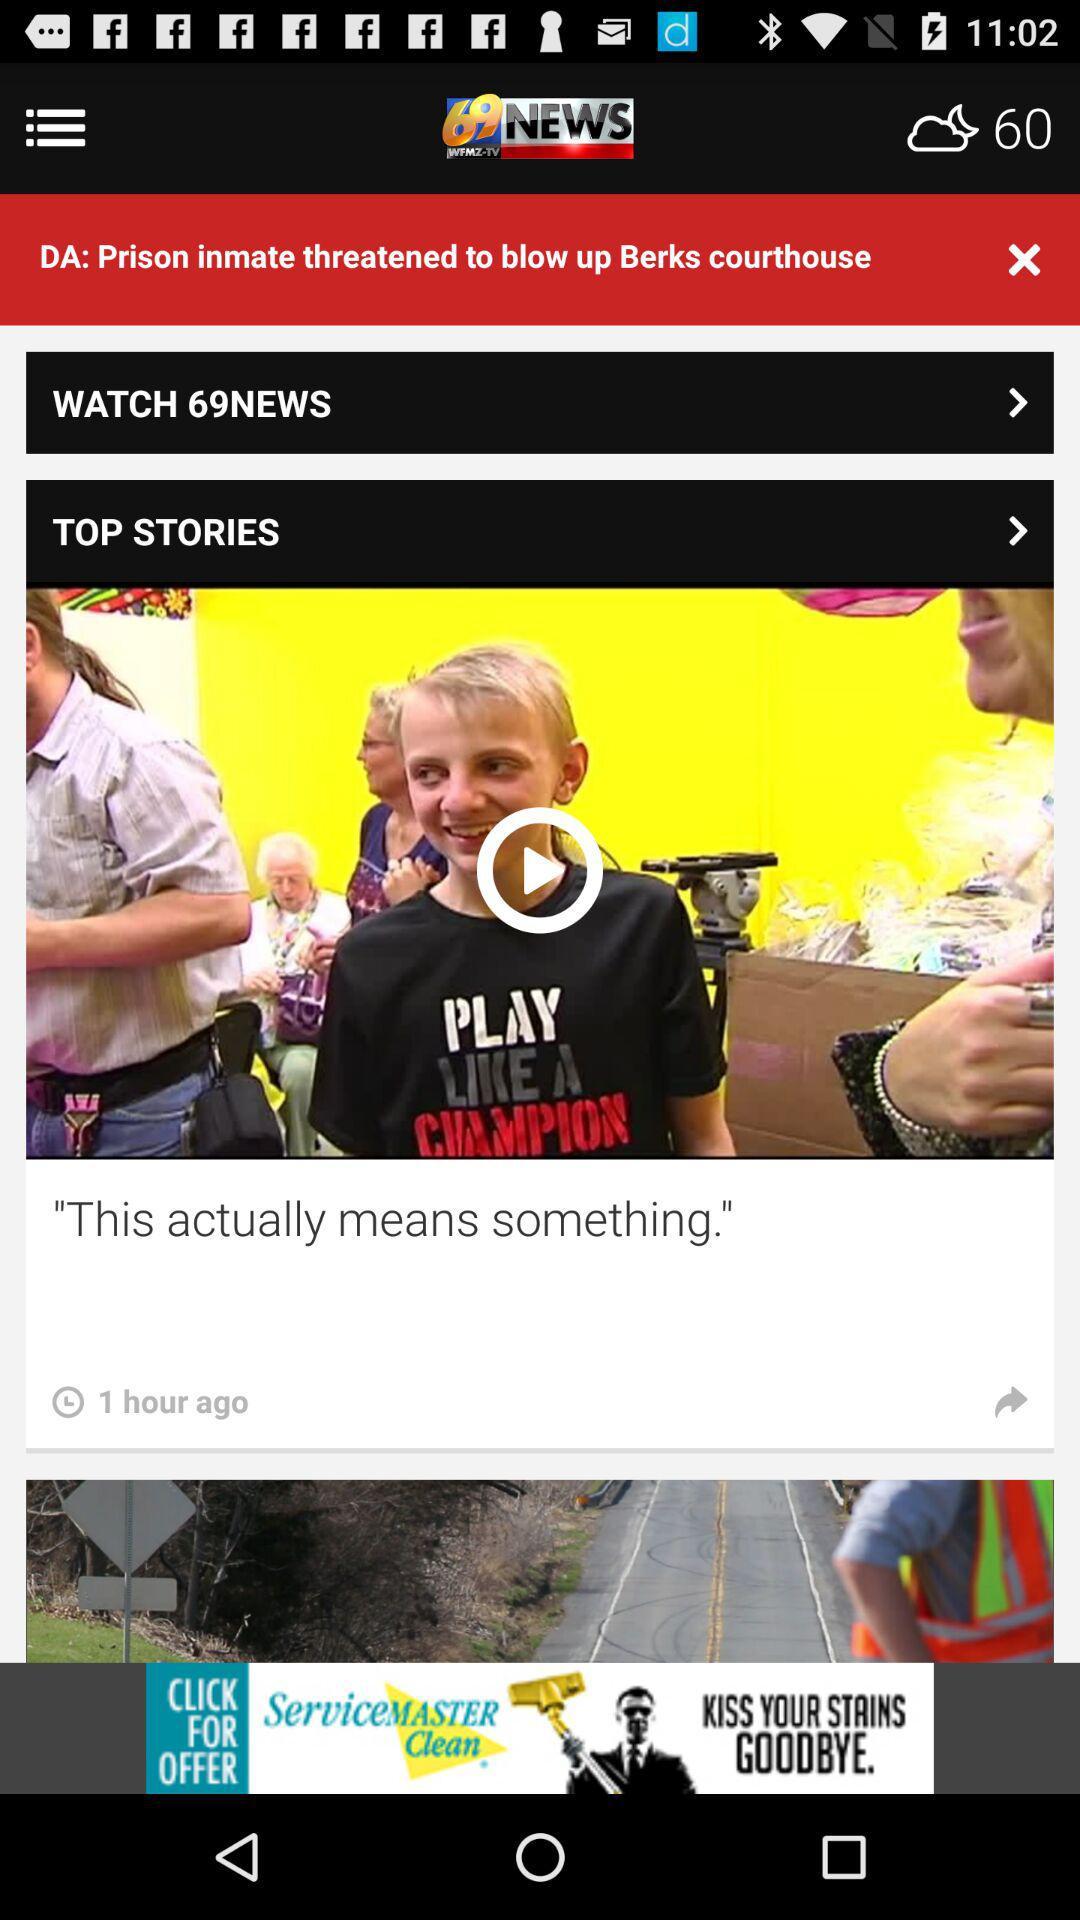What is the application name? The application name is "69 WFMZ-TV NEWS". 